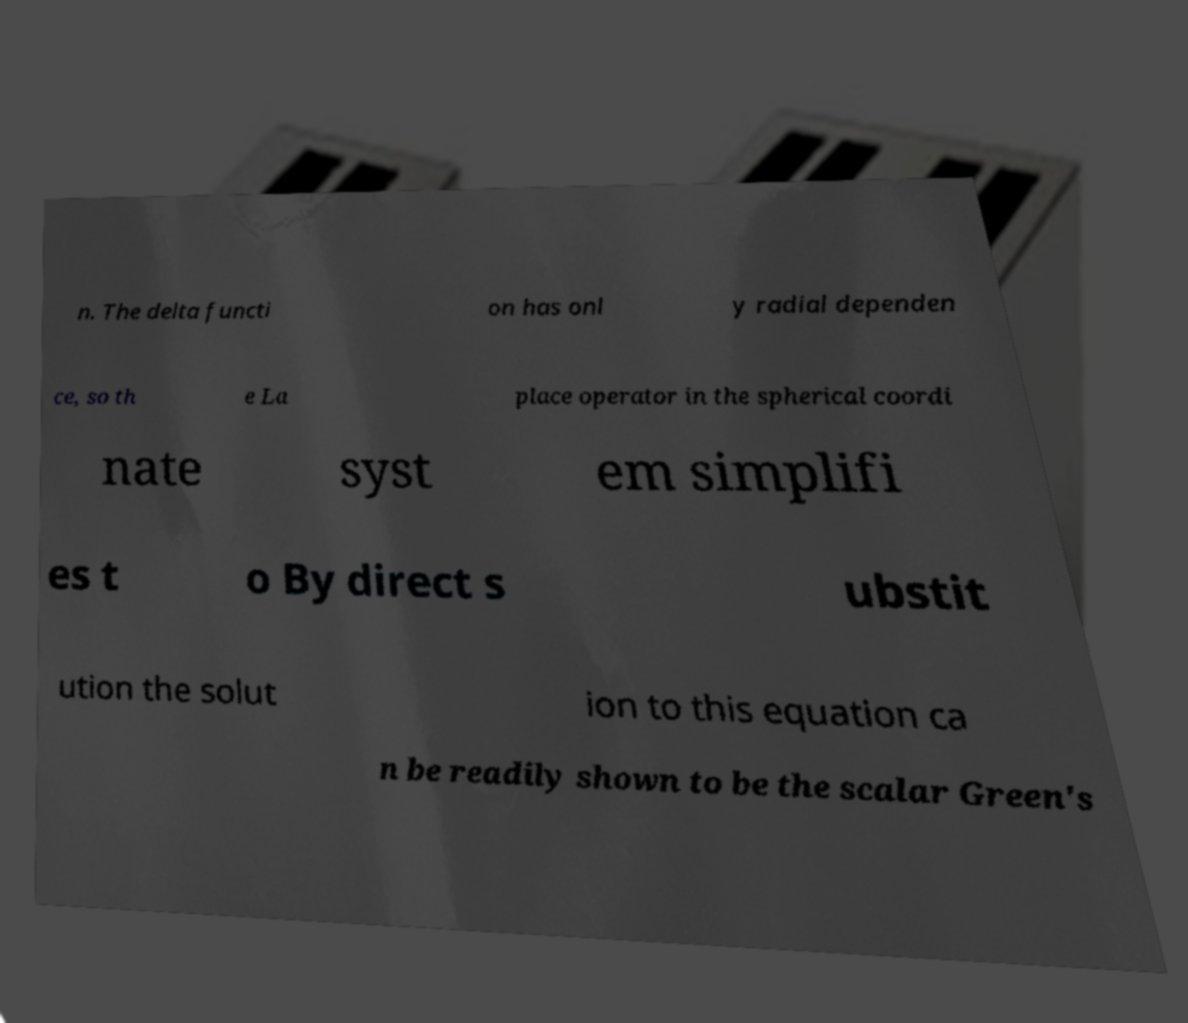Please identify and transcribe the text found in this image. n. The delta functi on has onl y radial dependen ce, so th e La place operator in the spherical coordi nate syst em simplifi es t o By direct s ubstit ution the solut ion to this equation ca n be readily shown to be the scalar Green's 